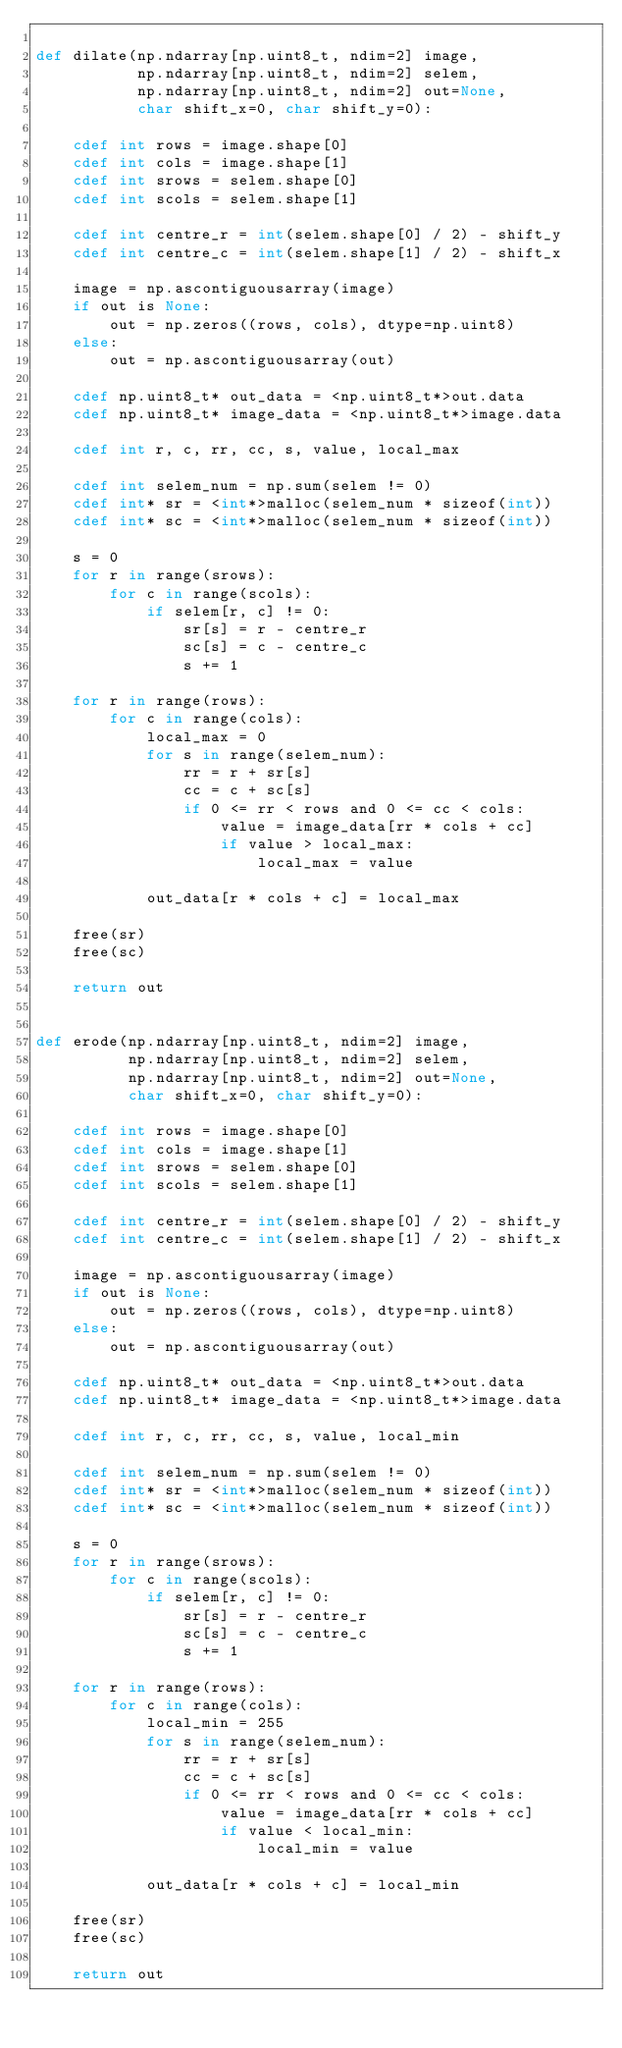Convert code to text. <code><loc_0><loc_0><loc_500><loc_500><_Cython_>
def dilate(np.ndarray[np.uint8_t, ndim=2] image,
           np.ndarray[np.uint8_t, ndim=2] selem,
           np.ndarray[np.uint8_t, ndim=2] out=None,
           char shift_x=0, char shift_y=0):

    cdef int rows = image.shape[0]
    cdef int cols = image.shape[1]
    cdef int srows = selem.shape[0]
    cdef int scols = selem.shape[1]

    cdef int centre_r = int(selem.shape[0] / 2) - shift_y
    cdef int centre_c = int(selem.shape[1] / 2) - shift_x

    image = np.ascontiguousarray(image)
    if out is None:
        out = np.zeros((rows, cols), dtype=np.uint8)
    else:
        out = np.ascontiguousarray(out)

    cdef np.uint8_t* out_data = <np.uint8_t*>out.data
    cdef np.uint8_t* image_data = <np.uint8_t*>image.data

    cdef int r, c, rr, cc, s, value, local_max

    cdef int selem_num = np.sum(selem != 0)
    cdef int* sr = <int*>malloc(selem_num * sizeof(int))
    cdef int* sc = <int*>malloc(selem_num * sizeof(int))

    s = 0
    for r in range(srows):
        for c in range(scols):
            if selem[r, c] != 0:
                sr[s] = r - centre_r
                sc[s] = c - centre_c
                s += 1

    for r in range(rows):
        for c in range(cols):
            local_max = 0
            for s in range(selem_num):
                rr = r + sr[s]
                cc = c + sc[s]
                if 0 <= rr < rows and 0 <= cc < cols:
                    value = image_data[rr * cols + cc]
                    if value > local_max:
                        local_max = value

            out_data[r * cols + c] = local_max

    free(sr)
    free(sc)

    return out


def erode(np.ndarray[np.uint8_t, ndim=2] image,
          np.ndarray[np.uint8_t, ndim=2] selem,
          np.ndarray[np.uint8_t, ndim=2] out=None,
          char shift_x=0, char shift_y=0):

    cdef int rows = image.shape[0]
    cdef int cols = image.shape[1]
    cdef int srows = selem.shape[0]
    cdef int scols = selem.shape[1]

    cdef int centre_r = int(selem.shape[0] / 2) - shift_y
    cdef int centre_c = int(selem.shape[1] / 2) - shift_x

    image = np.ascontiguousarray(image)
    if out is None:
        out = np.zeros((rows, cols), dtype=np.uint8)
    else:
        out = np.ascontiguousarray(out)

    cdef np.uint8_t* out_data = <np.uint8_t*>out.data
    cdef np.uint8_t* image_data = <np.uint8_t*>image.data

    cdef int r, c, rr, cc, s, value, local_min

    cdef int selem_num = np.sum(selem != 0)
    cdef int* sr = <int*>malloc(selem_num * sizeof(int))
    cdef int* sc = <int*>malloc(selem_num * sizeof(int))

    s = 0
    for r in range(srows):
        for c in range(scols):
            if selem[r, c] != 0:
                sr[s] = r - centre_r
                sc[s] = c - centre_c
                s += 1

    for r in range(rows):
        for c in range(cols):
            local_min = 255
            for s in range(selem_num):
                rr = r + sr[s]
                cc = c + sc[s]
                if 0 <= rr < rows and 0 <= cc < cols:
                    value = image_data[rr * cols + cc]
                    if value < local_min:
                        local_min = value

            out_data[r * cols + c] = local_min

    free(sr)
    free(sc)

    return out
</code> 